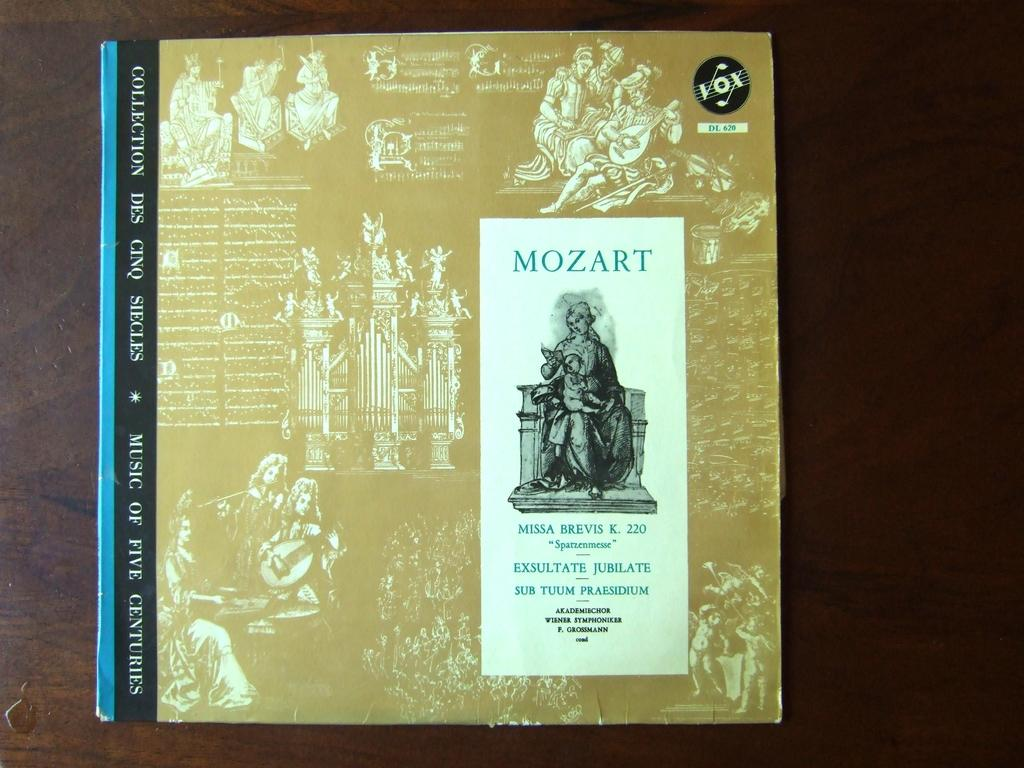<image>
Summarize the visual content of the image. A Mozart album collection with a vox logo on the top right. 